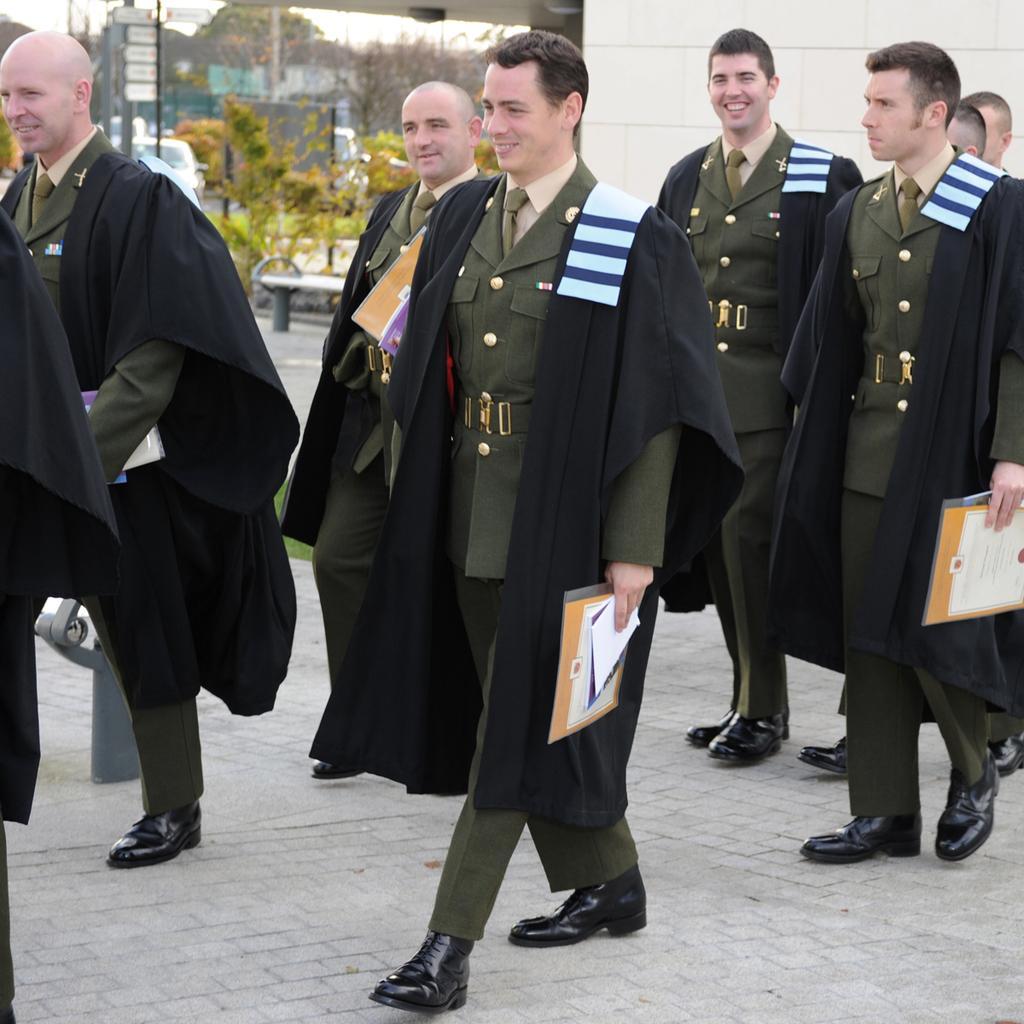Could you give a brief overview of what you see in this image? In this image I see few men who are wearing same uniform and I see that these 4 of them are smiling and I see that these 3 of them are holding few things in their hands and I see the path. In the background I see the plants, a car over here, boards and the trees and I see the wall. 